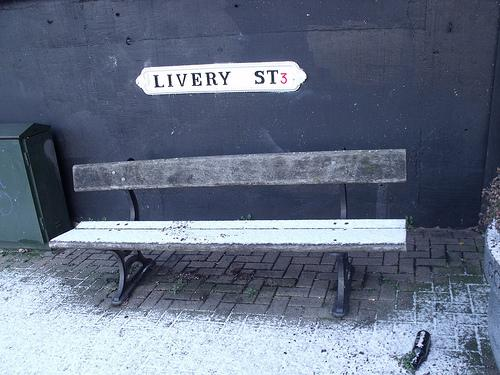Question: what is the street?
Choices:
A. First.
B. Second.
C. Broadway.
D. Livery.
Answer with the letter. Answer: D Question: what color is the sign?
Choices:
A. Red with white lettering.
B. Yellow with black lettering.
C. White with black letters.
D. Orange with blue lettering.
Answer with the letter. Answer: C Question: why is the bench there?
Choices:
A. So I can sit.
B. Decoration.
C. So pedestrians can sit.
D. Men put it there.
Answer with the letter. Answer: C 